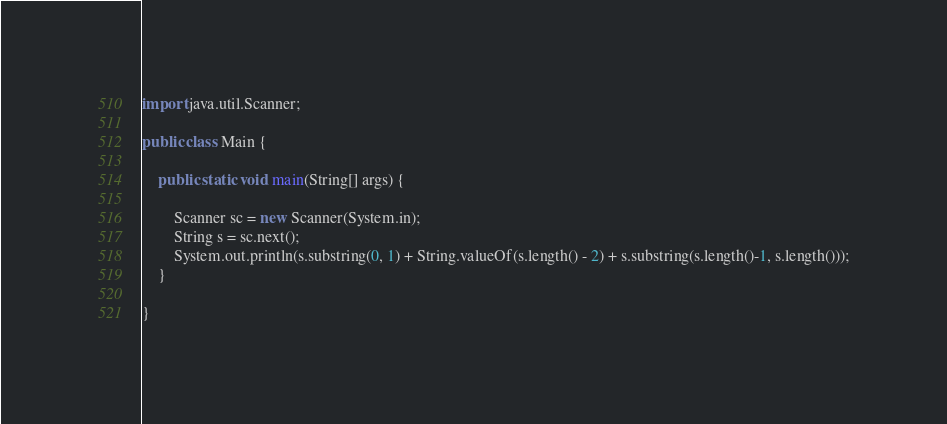Convert code to text. <code><loc_0><loc_0><loc_500><loc_500><_Java_>import java.util.Scanner;

public class Main {

	public static void main(String[] args) {

		Scanner sc = new Scanner(System.in);
		String s = sc.next();
		System.out.println(s.substring(0, 1) + String.valueOf(s.length() - 2) + s.substring(s.length()-1, s.length()));
	}

}
</code> 